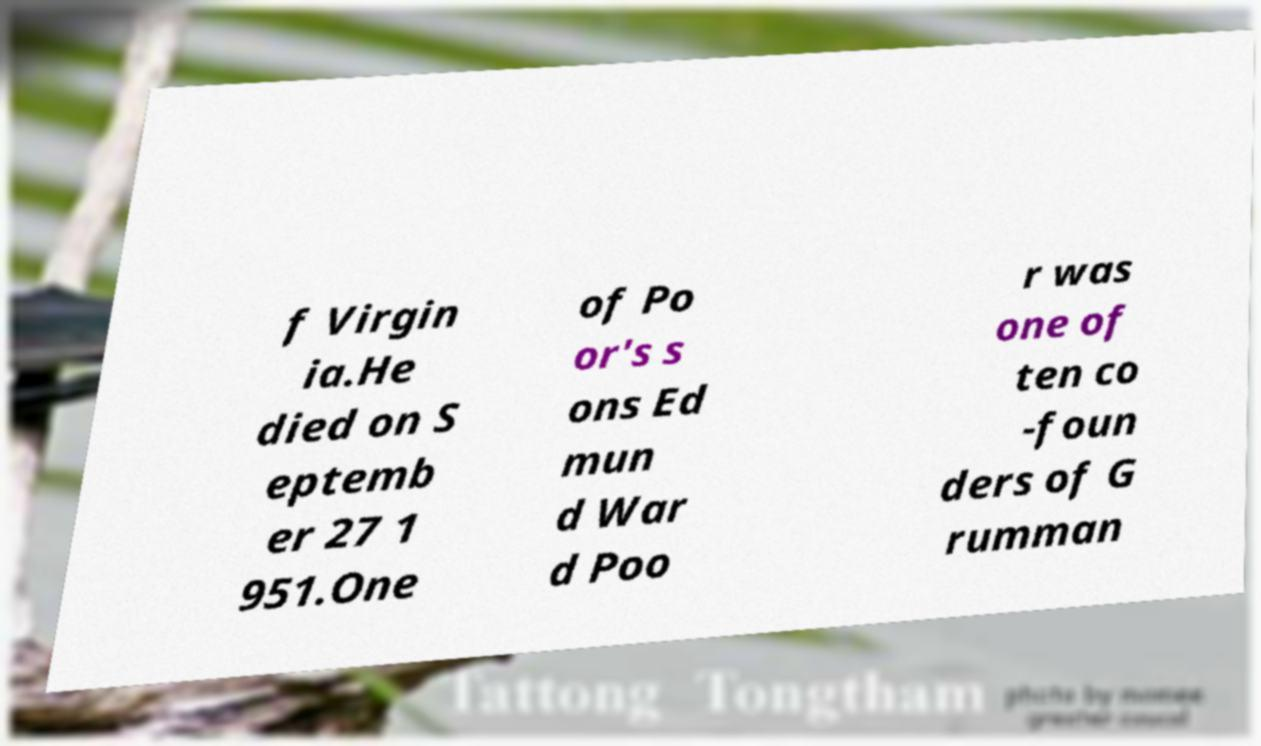Could you assist in decoding the text presented in this image and type it out clearly? f Virgin ia.He died on S eptemb er 27 1 951.One of Po or's s ons Ed mun d War d Poo r was one of ten co -foun ders of G rumman 